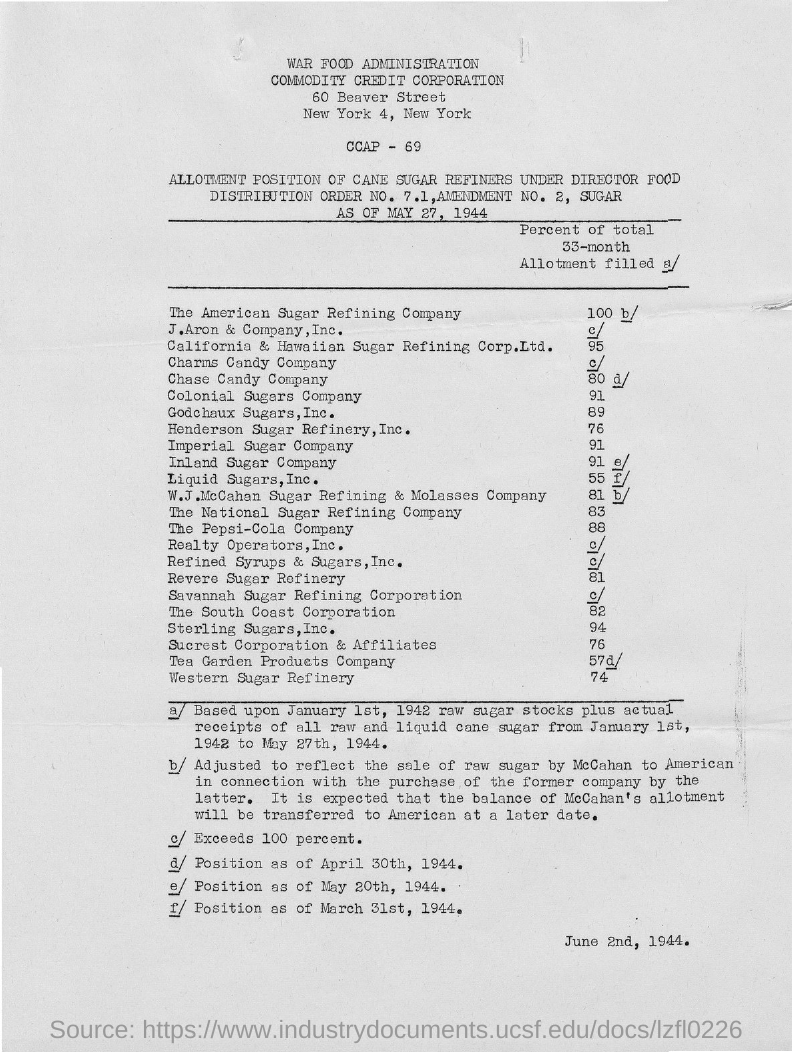Highlight a few significant elements in this photo. The percentage of Western Sugar Refinery is 74%. The date noted at the bottom right of the document is June 2nd, 1944. The percentage of total production for Colonial Sugars Company was 91%. The letterhead displays the name of a city, and that city is New York. Out of the total revenue of the National Sugar Refining Company, 83% was generated in the specified period. 